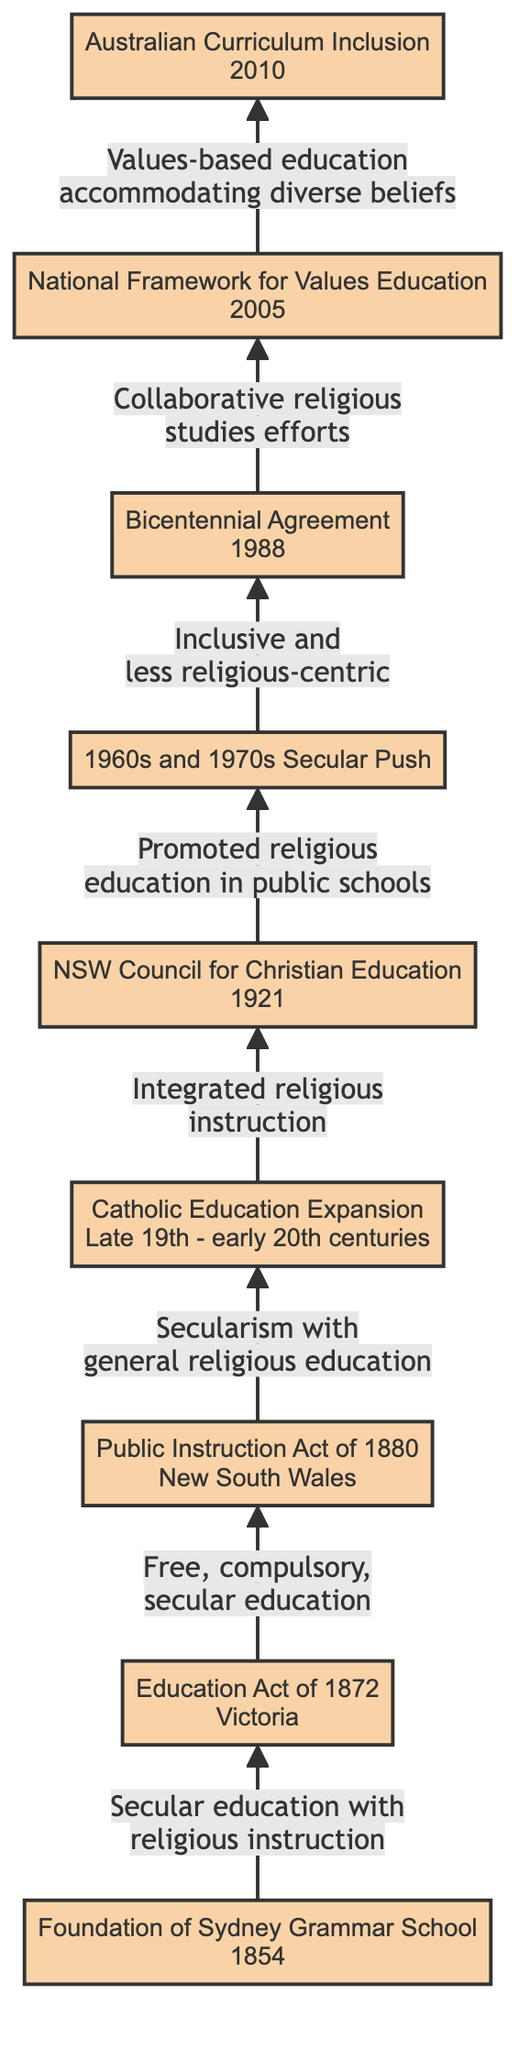What year was the Foundation of Sydney Grammar School established? The diagram specifies that the Foundation of Sydney Grammar School was established in 1854, indicated clearly in the first node of the flowchart.
Answer: 1854 What does the Education Act of 1872 in Victoria mandate? The diagram notes that the Education Act of 1872 mandates "free, compulsory, secular education," and this instruction is presented in the second node of the flowchart.
Answer: Free, compulsory, secular education How many nodes are in the flowchart? By counting the nodes illustrated in the diagram, there are ten specific events or milestones related to religious education policies in Australian schools, all depicted as nodes in the flowchart.
Answer: 10 What change did the 1960s and 1970s push bring about in religious education? The flowchart labels the change brought by the 1960s and 1970s as a "secular push," which emphasizes inclusivity and a movement away from religious-centric policies. This change is detailed in node six.
Answer: Inclusive and less religious-centric What is the significance of the Bicentennial Agreement of 1988? The diagram indicates that the Bicentennial Agreement of 1988 marks Australia's bicentenary and reinforces "collaborative efforts in religious studies," showing the importance of joint efforts in educational policy over that period.
Answer: Collaborative religious studies efforts How did the establishment of the NSW Council for Christian Education influence public schools? According to the flowchart, the establishment of the NSW Council for Christian Education in 1921 is directly connected to promoting religious education within public schools, as stated in node five of the diagram.
Answer: Promoted religious education in public schools What overarching theme does the National Framework for Values Education in 2005 highlight? The diagram points out that the National Framework for Values Education in 2005 encourages "values-based education" while accommodating diverse religious beliefs, emphasizing the need for a broad and inclusive educational approach.
Answer: Values-based education accommodating diverse beliefs Which node emphasizes the integration of intense religious instruction? When examining the flowchart, node four details the "Catholic Education Expansion" as the moment that saw the proliferation of Catholic schools that incorporated "intense religious instruction." This highlights the strong integration aspect of religious education.
Answer: Catholic Education Expansion What was included in the Australian Curriculum in 2010? The diagram outlines that the Australian Curriculum, updated in 2010, includes "dimensions for Religious Education," specifically focusing on "ethical understanding and intercultural awareness." This indicates the educational priorities in later policies.
Answer: Dimensions for Religious Education 